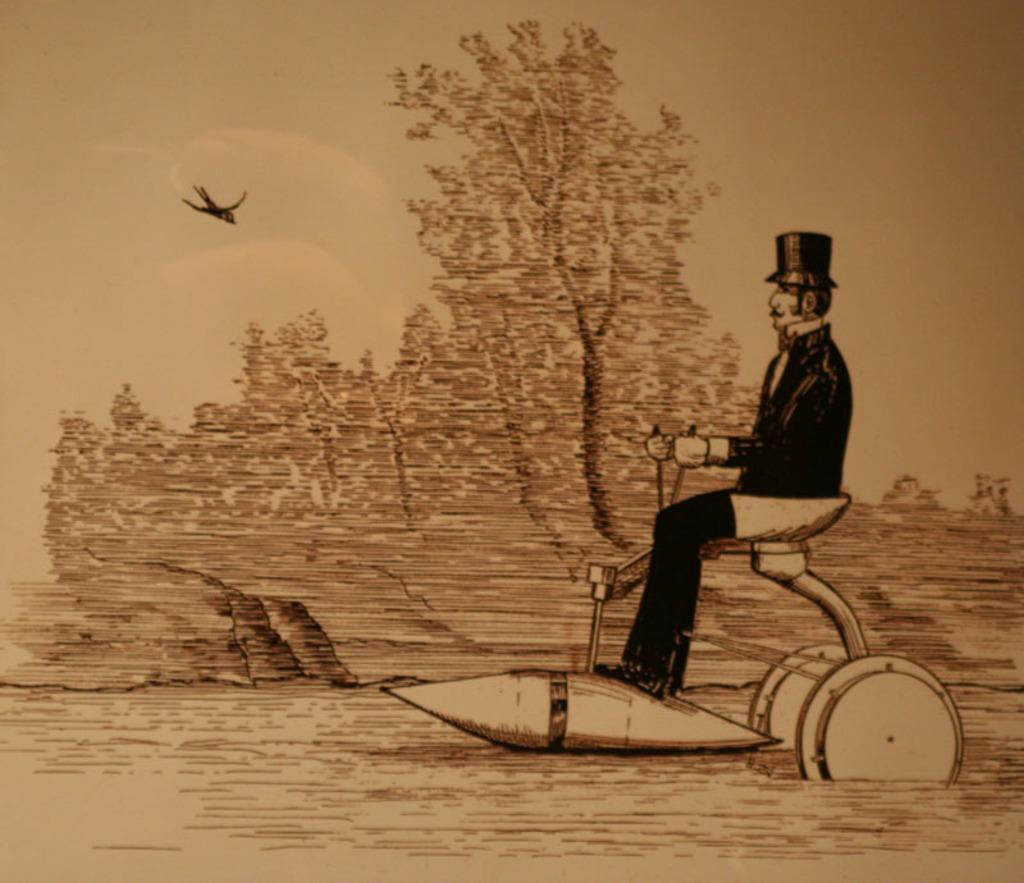What type of artwork is depicted in the image? The image is a painting. What is the man in the image doing? The man is on a vehicle in the image. What can be seen in the background of the painting? There are trees, a bird, the sky, and clouds in the background of the image. Where is the drawer located in the image? There is no drawer present in the image. What color is the ink used by the woman in the image? There is no woman or ink present in the image. 